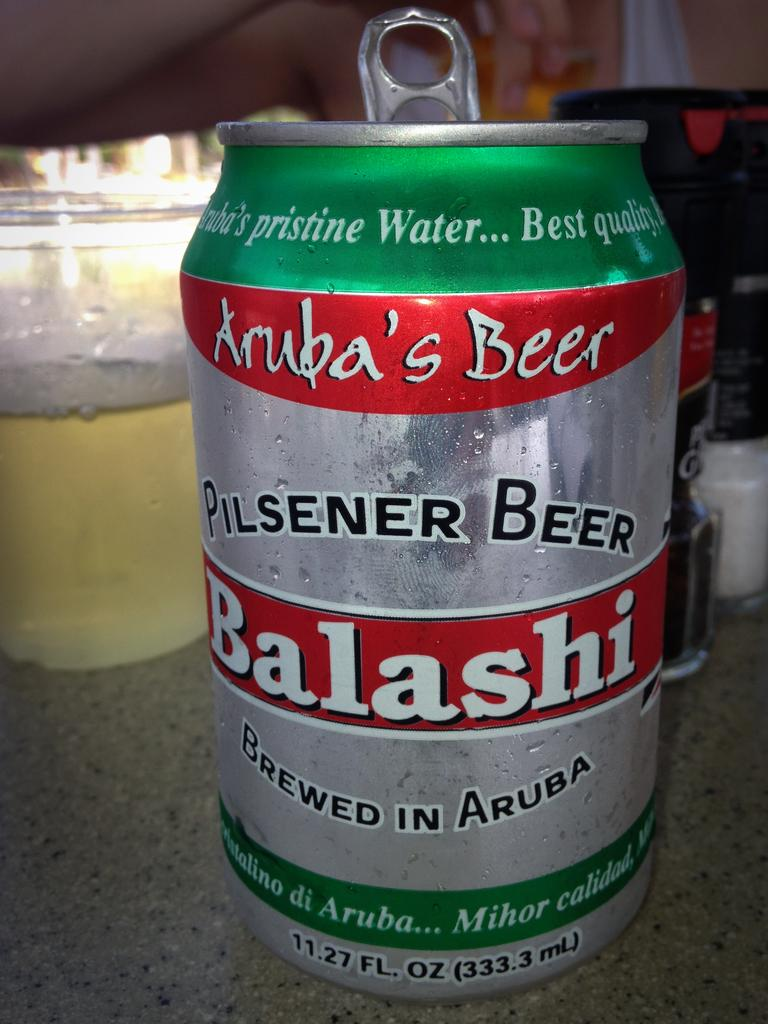<image>
Relay a brief, clear account of the picture shown. An opened can of Balashi pilsener beer brewed in Aruba 